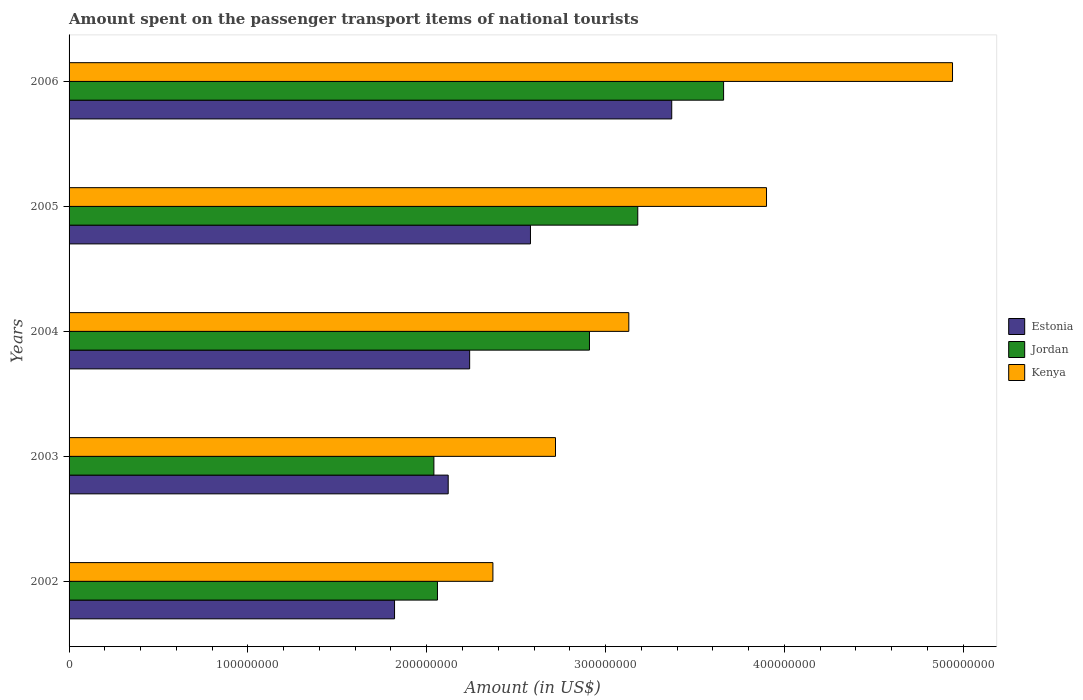How many different coloured bars are there?
Offer a terse response. 3. How many bars are there on the 1st tick from the bottom?
Ensure brevity in your answer.  3. What is the amount spent on the passenger transport items of national tourists in Jordan in 2003?
Offer a very short reply. 2.04e+08. Across all years, what is the maximum amount spent on the passenger transport items of national tourists in Kenya?
Provide a succinct answer. 4.94e+08. Across all years, what is the minimum amount spent on the passenger transport items of national tourists in Jordan?
Your response must be concise. 2.04e+08. In which year was the amount spent on the passenger transport items of national tourists in Estonia maximum?
Provide a short and direct response. 2006. What is the total amount spent on the passenger transport items of national tourists in Estonia in the graph?
Your answer should be very brief. 1.21e+09. What is the difference between the amount spent on the passenger transport items of national tourists in Estonia in 2005 and that in 2006?
Ensure brevity in your answer.  -7.90e+07. What is the difference between the amount spent on the passenger transport items of national tourists in Estonia in 2006 and the amount spent on the passenger transport items of national tourists in Kenya in 2003?
Provide a succinct answer. 6.50e+07. What is the average amount spent on the passenger transport items of national tourists in Kenya per year?
Make the answer very short. 3.41e+08. In the year 2004, what is the difference between the amount spent on the passenger transport items of national tourists in Kenya and amount spent on the passenger transport items of national tourists in Estonia?
Offer a terse response. 8.90e+07. In how many years, is the amount spent on the passenger transport items of national tourists in Estonia greater than 160000000 US$?
Make the answer very short. 5. What is the ratio of the amount spent on the passenger transport items of national tourists in Jordan in 2002 to that in 2003?
Offer a very short reply. 1.01. What is the difference between the highest and the second highest amount spent on the passenger transport items of national tourists in Jordan?
Provide a short and direct response. 4.80e+07. What is the difference between the highest and the lowest amount spent on the passenger transport items of national tourists in Kenya?
Keep it short and to the point. 2.57e+08. In how many years, is the amount spent on the passenger transport items of national tourists in Jordan greater than the average amount spent on the passenger transport items of national tourists in Jordan taken over all years?
Your answer should be compact. 3. What does the 1st bar from the top in 2006 represents?
Your answer should be compact. Kenya. What does the 1st bar from the bottom in 2002 represents?
Offer a very short reply. Estonia. Are all the bars in the graph horizontal?
Your answer should be very brief. Yes. How many legend labels are there?
Give a very brief answer. 3. How are the legend labels stacked?
Offer a terse response. Vertical. What is the title of the graph?
Give a very brief answer. Amount spent on the passenger transport items of national tourists. Does "Greece" appear as one of the legend labels in the graph?
Provide a short and direct response. No. What is the label or title of the Y-axis?
Your answer should be very brief. Years. What is the Amount (in US$) in Estonia in 2002?
Your response must be concise. 1.82e+08. What is the Amount (in US$) of Jordan in 2002?
Your response must be concise. 2.06e+08. What is the Amount (in US$) of Kenya in 2002?
Make the answer very short. 2.37e+08. What is the Amount (in US$) in Estonia in 2003?
Offer a terse response. 2.12e+08. What is the Amount (in US$) of Jordan in 2003?
Ensure brevity in your answer.  2.04e+08. What is the Amount (in US$) of Kenya in 2003?
Ensure brevity in your answer.  2.72e+08. What is the Amount (in US$) in Estonia in 2004?
Your response must be concise. 2.24e+08. What is the Amount (in US$) in Jordan in 2004?
Make the answer very short. 2.91e+08. What is the Amount (in US$) in Kenya in 2004?
Make the answer very short. 3.13e+08. What is the Amount (in US$) of Estonia in 2005?
Give a very brief answer. 2.58e+08. What is the Amount (in US$) of Jordan in 2005?
Provide a short and direct response. 3.18e+08. What is the Amount (in US$) in Kenya in 2005?
Your answer should be very brief. 3.90e+08. What is the Amount (in US$) in Estonia in 2006?
Make the answer very short. 3.37e+08. What is the Amount (in US$) of Jordan in 2006?
Offer a very short reply. 3.66e+08. What is the Amount (in US$) in Kenya in 2006?
Provide a succinct answer. 4.94e+08. Across all years, what is the maximum Amount (in US$) of Estonia?
Your answer should be very brief. 3.37e+08. Across all years, what is the maximum Amount (in US$) in Jordan?
Ensure brevity in your answer.  3.66e+08. Across all years, what is the maximum Amount (in US$) of Kenya?
Provide a short and direct response. 4.94e+08. Across all years, what is the minimum Amount (in US$) of Estonia?
Make the answer very short. 1.82e+08. Across all years, what is the minimum Amount (in US$) in Jordan?
Ensure brevity in your answer.  2.04e+08. Across all years, what is the minimum Amount (in US$) in Kenya?
Your response must be concise. 2.37e+08. What is the total Amount (in US$) of Estonia in the graph?
Keep it short and to the point. 1.21e+09. What is the total Amount (in US$) in Jordan in the graph?
Provide a short and direct response. 1.38e+09. What is the total Amount (in US$) of Kenya in the graph?
Your answer should be very brief. 1.71e+09. What is the difference between the Amount (in US$) in Estonia in 2002 and that in 2003?
Make the answer very short. -3.00e+07. What is the difference between the Amount (in US$) of Jordan in 2002 and that in 2003?
Ensure brevity in your answer.  2.00e+06. What is the difference between the Amount (in US$) of Kenya in 2002 and that in 2003?
Your response must be concise. -3.50e+07. What is the difference between the Amount (in US$) in Estonia in 2002 and that in 2004?
Your response must be concise. -4.20e+07. What is the difference between the Amount (in US$) of Jordan in 2002 and that in 2004?
Provide a short and direct response. -8.50e+07. What is the difference between the Amount (in US$) of Kenya in 2002 and that in 2004?
Ensure brevity in your answer.  -7.60e+07. What is the difference between the Amount (in US$) in Estonia in 2002 and that in 2005?
Your response must be concise. -7.60e+07. What is the difference between the Amount (in US$) in Jordan in 2002 and that in 2005?
Provide a succinct answer. -1.12e+08. What is the difference between the Amount (in US$) of Kenya in 2002 and that in 2005?
Provide a short and direct response. -1.53e+08. What is the difference between the Amount (in US$) in Estonia in 2002 and that in 2006?
Your answer should be compact. -1.55e+08. What is the difference between the Amount (in US$) in Jordan in 2002 and that in 2006?
Keep it short and to the point. -1.60e+08. What is the difference between the Amount (in US$) in Kenya in 2002 and that in 2006?
Provide a succinct answer. -2.57e+08. What is the difference between the Amount (in US$) of Estonia in 2003 and that in 2004?
Offer a terse response. -1.20e+07. What is the difference between the Amount (in US$) in Jordan in 2003 and that in 2004?
Provide a short and direct response. -8.70e+07. What is the difference between the Amount (in US$) of Kenya in 2003 and that in 2004?
Keep it short and to the point. -4.10e+07. What is the difference between the Amount (in US$) in Estonia in 2003 and that in 2005?
Give a very brief answer. -4.60e+07. What is the difference between the Amount (in US$) in Jordan in 2003 and that in 2005?
Ensure brevity in your answer.  -1.14e+08. What is the difference between the Amount (in US$) of Kenya in 2003 and that in 2005?
Your response must be concise. -1.18e+08. What is the difference between the Amount (in US$) of Estonia in 2003 and that in 2006?
Provide a succinct answer. -1.25e+08. What is the difference between the Amount (in US$) in Jordan in 2003 and that in 2006?
Keep it short and to the point. -1.62e+08. What is the difference between the Amount (in US$) in Kenya in 2003 and that in 2006?
Offer a terse response. -2.22e+08. What is the difference between the Amount (in US$) of Estonia in 2004 and that in 2005?
Give a very brief answer. -3.40e+07. What is the difference between the Amount (in US$) of Jordan in 2004 and that in 2005?
Give a very brief answer. -2.70e+07. What is the difference between the Amount (in US$) of Kenya in 2004 and that in 2005?
Give a very brief answer. -7.70e+07. What is the difference between the Amount (in US$) of Estonia in 2004 and that in 2006?
Offer a very short reply. -1.13e+08. What is the difference between the Amount (in US$) of Jordan in 2004 and that in 2006?
Provide a short and direct response. -7.50e+07. What is the difference between the Amount (in US$) in Kenya in 2004 and that in 2006?
Your response must be concise. -1.81e+08. What is the difference between the Amount (in US$) of Estonia in 2005 and that in 2006?
Make the answer very short. -7.90e+07. What is the difference between the Amount (in US$) in Jordan in 2005 and that in 2006?
Your answer should be very brief. -4.80e+07. What is the difference between the Amount (in US$) in Kenya in 2005 and that in 2006?
Make the answer very short. -1.04e+08. What is the difference between the Amount (in US$) of Estonia in 2002 and the Amount (in US$) of Jordan in 2003?
Offer a terse response. -2.20e+07. What is the difference between the Amount (in US$) of Estonia in 2002 and the Amount (in US$) of Kenya in 2003?
Offer a terse response. -9.00e+07. What is the difference between the Amount (in US$) of Jordan in 2002 and the Amount (in US$) of Kenya in 2003?
Make the answer very short. -6.60e+07. What is the difference between the Amount (in US$) of Estonia in 2002 and the Amount (in US$) of Jordan in 2004?
Offer a very short reply. -1.09e+08. What is the difference between the Amount (in US$) in Estonia in 2002 and the Amount (in US$) in Kenya in 2004?
Offer a very short reply. -1.31e+08. What is the difference between the Amount (in US$) of Jordan in 2002 and the Amount (in US$) of Kenya in 2004?
Your answer should be very brief. -1.07e+08. What is the difference between the Amount (in US$) in Estonia in 2002 and the Amount (in US$) in Jordan in 2005?
Offer a terse response. -1.36e+08. What is the difference between the Amount (in US$) in Estonia in 2002 and the Amount (in US$) in Kenya in 2005?
Your answer should be very brief. -2.08e+08. What is the difference between the Amount (in US$) of Jordan in 2002 and the Amount (in US$) of Kenya in 2005?
Offer a very short reply. -1.84e+08. What is the difference between the Amount (in US$) of Estonia in 2002 and the Amount (in US$) of Jordan in 2006?
Your response must be concise. -1.84e+08. What is the difference between the Amount (in US$) of Estonia in 2002 and the Amount (in US$) of Kenya in 2006?
Ensure brevity in your answer.  -3.12e+08. What is the difference between the Amount (in US$) in Jordan in 2002 and the Amount (in US$) in Kenya in 2006?
Keep it short and to the point. -2.88e+08. What is the difference between the Amount (in US$) of Estonia in 2003 and the Amount (in US$) of Jordan in 2004?
Offer a very short reply. -7.90e+07. What is the difference between the Amount (in US$) in Estonia in 2003 and the Amount (in US$) in Kenya in 2004?
Make the answer very short. -1.01e+08. What is the difference between the Amount (in US$) in Jordan in 2003 and the Amount (in US$) in Kenya in 2004?
Offer a terse response. -1.09e+08. What is the difference between the Amount (in US$) in Estonia in 2003 and the Amount (in US$) in Jordan in 2005?
Provide a short and direct response. -1.06e+08. What is the difference between the Amount (in US$) of Estonia in 2003 and the Amount (in US$) of Kenya in 2005?
Ensure brevity in your answer.  -1.78e+08. What is the difference between the Amount (in US$) in Jordan in 2003 and the Amount (in US$) in Kenya in 2005?
Keep it short and to the point. -1.86e+08. What is the difference between the Amount (in US$) of Estonia in 2003 and the Amount (in US$) of Jordan in 2006?
Provide a short and direct response. -1.54e+08. What is the difference between the Amount (in US$) of Estonia in 2003 and the Amount (in US$) of Kenya in 2006?
Your answer should be very brief. -2.82e+08. What is the difference between the Amount (in US$) of Jordan in 2003 and the Amount (in US$) of Kenya in 2006?
Keep it short and to the point. -2.90e+08. What is the difference between the Amount (in US$) in Estonia in 2004 and the Amount (in US$) in Jordan in 2005?
Give a very brief answer. -9.40e+07. What is the difference between the Amount (in US$) of Estonia in 2004 and the Amount (in US$) of Kenya in 2005?
Offer a very short reply. -1.66e+08. What is the difference between the Amount (in US$) of Jordan in 2004 and the Amount (in US$) of Kenya in 2005?
Offer a very short reply. -9.90e+07. What is the difference between the Amount (in US$) of Estonia in 2004 and the Amount (in US$) of Jordan in 2006?
Provide a succinct answer. -1.42e+08. What is the difference between the Amount (in US$) in Estonia in 2004 and the Amount (in US$) in Kenya in 2006?
Offer a terse response. -2.70e+08. What is the difference between the Amount (in US$) in Jordan in 2004 and the Amount (in US$) in Kenya in 2006?
Keep it short and to the point. -2.03e+08. What is the difference between the Amount (in US$) of Estonia in 2005 and the Amount (in US$) of Jordan in 2006?
Ensure brevity in your answer.  -1.08e+08. What is the difference between the Amount (in US$) in Estonia in 2005 and the Amount (in US$) in Kenya in 2006?
Your answer should be compact. -2.36e+08. What is the difference between the Amount (in US$) in Jordan in 2005 and the Amount (in US$) in Kenya in 2006?
Ensure brevity in your answer.  -1.76e+08. What is the average Amount (in US$) of Estonia per year?
Your answer should be very brief. 2.43e+08. What is the average Amount (in US$) of Jordan per year?
Give a very brief answer. 2.77e+08. What is the average Amount (in US$) of Kenya per year?
Provide a succinct answer. 3.41e+08. In the year 2002, what is the difference between the Amount (in US$) of Estonia and Amount (in US$) of Jordan?
Your answer should be compact. -2.40e+07. In the year 2002, what is the difference between the Amount (in US$) in Estonia and Amount (in US$) in Kenya?
Give a very brief answer. -5.50e+07. In the year 2002, what is the difference between the Amount (in US$) of Jordan and Amount (in US$) of Kenya?
Offer a very short reply. -3.10e+07. In the year 2003, what is the difference between the Amount (in US$) in Estonia and Amount (in US$) in Jordan?
Your response must be concise. 8.00e+06. In the year 2003, what is the difference between the Amount (in US$) in Estonia and Amount (in US$) in Kenya?
Give a very brief answer. -6.00e+07. In the year 2003, what is the difference between the Amount (in US$) of Jordan and Amount (in US$) of Kenya?
Provide a succinct answer. -6.80e+07. In the year 2004, what is the difference between the Amount (in US$) of Estonia and Amount (in US$) of Jordan?
Make the answer very short. -6.70e+07. In the year 2004, what is the difference between the Amount (in US$) in Estonia and Amount (in US$) in Kenya?
Keep it short and to the point. -8.90e+07. In the year 2004, what is the difference between the Amount (in US$) in Jordan and Amount (in US$) in Kenya?
Give a very brief answer. -2.20e+07. In the year 2005, what is the difference between the Amount (in US$) in Estonia and Amount (in US$) in Jordan?
Provide a short and direct response. -6.00e+07. In the year 2005, what is the difference between the Amount (in US$) in Estonia and Amount (in US$) in Kenya?
Keep it short and to the point. -1.32e+08. In the year 2005, what is the difference between the Amount (in US$) in Jordan and Amount (in US$) in Kenya?
Provide a succinct answer. -7.20e+07. In the year 2006, what is the difference between the Amount (in US$) of Estonia and Amount (in US$) of Jordan?
Your response must be concise. -2.90e+07. In the year 2006, what is the difference between the Amount (in US$) in Estonia and Amount (in US$) in Kenya?
Your response must be concise. -1.57e+08. In the year 2006, what is the difference between the Amount (in US$) of Jordan and Amount (in US$) of Kenya?
Your answer should be compact. -1.28e+08. What is the ratio of the Amount (in US$) of Estonia in 2002 to that in 2003?
Your answer should be compact. 0.86. What is the ratio of the Amount (in US$) in Jordan in 2002 to that in 2003?
Your answer should be very brief. 1.01. What is the ratio of the Amount (in US$) in Kenya in 2002 to that in 2003?
Your response must be concise. 0.87. What is the ratio of the Amount (in US$) of Estonia in 2002 to that in 2004?
Give a very brief answer. 0.81. What is the ratio of the Amount (in US$) of Jordan in 2002 to that in 2004?
Your answer should be very brief. 0.71. What is the ratio of the Amount (in US$) in Kenya in 2002 to that in 2004?
Provide a succinct answer. 0.76. What is the ratio of the Amount (in US$) of Estonia in 2002 to that in 2005?
Offer a terse response. 0.71. What is the ratio of the Amount (in US$) of Jordan in 2002 to that in 2005?
Give a very brief answer. 0.65. What is the ratio of the Amount (in US$) of Kenya in 2002 to that in 2005?
Offer a very short reply. 0.61. What is the ratio of the Amount (in US$) of Estonia in 2002 to that in 2006?
Your answer should be compact. 0.54. What is the ratio of the Amount (in US$) of Jordan in 2002 to that in 2006?
Your response must be concise. 0.56. What is the ratio of the Amount (in US$) in Kenya in 2002 to that in 2006?
Ensure brevity in your answer.  0.48. What is the ratio of the Amount (in US$) of Estonia in 2003 to that in 2004?
Your answer should be very brief. 0.95. What is the ratio of the Amount (in US$) in Jordan in 2003 to that in 2004?
Give a very brief answer. 0.7. What is the ratio of the Amount (in US$) of Kenya in 2003 to that in 2004?
Offer a very short reply. 0.87. What is the ratio of the Amount (in US$) in Estonia in 2003 to that in 2005?
Your response must be concise. 0.82. What is the ratio of the Amount (in US$) of Jordan in 2003 to that in 2005?
Your answer should be very brief. 0.64. What is the ratio of the Amount (in US$) in Kenya in 2003 to that in 2005?
Keep it short and to the point. 0.7. What is the ratio of the Amount (in US$) of Estonia in 2003 to that in 2006?
Make the answer very short. 0.63. What is the ratio of the Amount (in US$) in Jordan in 2003 to that in 2006?
Provide a succinct answer. 0.56. What is the ratio of the Amount (in US$) in Kenya in 2003 to that in 2006?
Ensure brevity in your answer.  0.55. What is the ratio of the Amount (in US$) of Estonia in 2004 to that in 2005?
Your response must be concise. 0.87. What is the ratio of the Amount (in US$) of Jordan in 2004 to that in 2005?
Offer a terse response. 0.92. What is the ratio of the Amount (in US$) in Kenya in 2004 to that in 2005?
Your answer should be compact. 0.8. What is the ratio of the Amount (in US$) in Estonia in 2004 to that in 2006?
Your answer should be compact. 0.66. What is the ratio of the Amount (in US$) of Jordan in 2004 to that in 2006?
Offer a very short reply. 0.8. What is the ratio of the Amount (in US$) of Kenya in 2004 to that in 2006?
Ensure brevity in your answer.  0.63. What is the ratio of the Amount (in US$) in Estonia in 2005 to that in 2006?
Your answer should be very brief. 0.77. What is the ratio of the Amount (in US$) of Jordan in 2005 to that in 2006?
Give a very brief answer. 0.87. What is the ratio of the Amount (in US$) in Kenya in 2005 to that in 2006?
Keep it short and to the point. 0.79. What is the difference between the highest and the second highest Amount (in US$) of Estonia?
Provide a short and direct response. 7.90e+07. What is the difference between the highest and the second highest Amount (in US$) of Jordan?
Offer a terse response. 4.80e+07. What is the difference between the highest and the second highest Amount (in US$) of Kenya?
Make the answer very short. 1.04e+08. What is the difference between the highest and the lowest Amount (in US$) in Estonia?
Provide a succinct answer. 1.55e+08. What is the difference between the highest and the lowest Amount (in US$) in Jordan?
Provide a short and direct response. 1.62e+08. What is the difference between the highest and the lowest Amount (in US$) of Kenya?
Provide a succinct answer. 2.57e+08. 